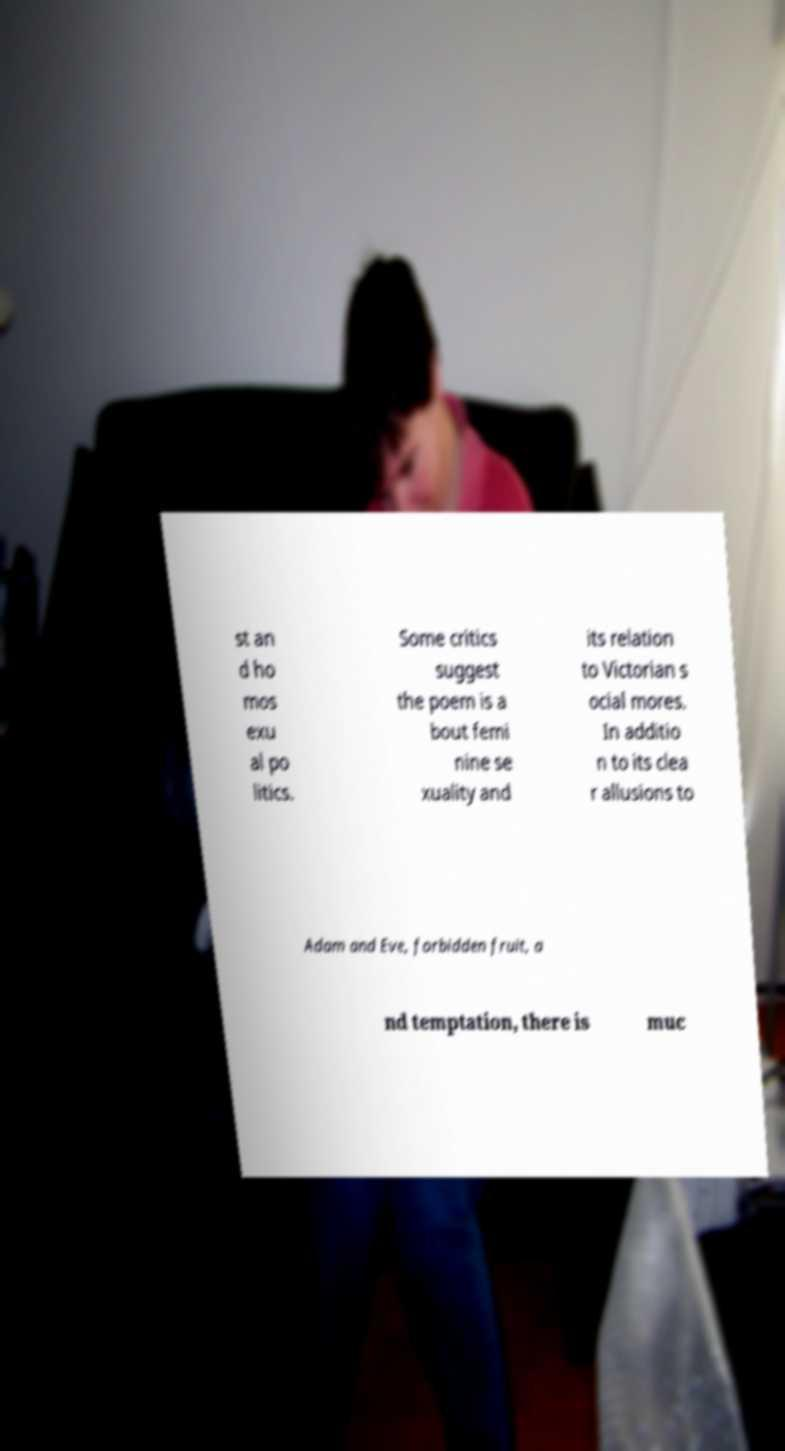I need the written content from this picture converted into text. Can you do that? st an d ho mos exu al po litics. Some critics suggest the poem is a bout femi nine se xuality and its relation to Victorian s ocial mores. In additio n to its clea r allusions to Adam and Eve, forbidden fruit, a nd temptation, there is muc 